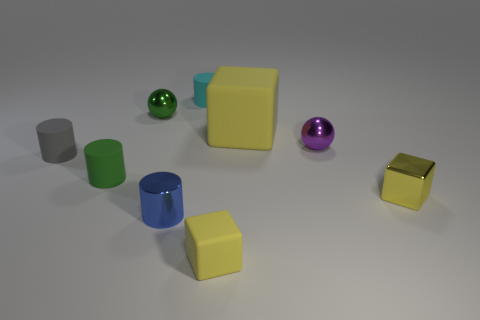What material is the green thing that is the same shape as the purple metal object?
Provide a succinct answer. Metal. Are there any other things that have the same material as the gray cylinder?
Your answer should be very brief. Yes. Are there any yellow things behind the blue thing?
Offer a terse response. Yes. What number of tiny things are there?
Offer a very short reply. 8. There is a tiny shiny ball behind the purple metal object; how many green things are to the left of it?
Offer a very short reply. 1. Is the color of the tiny metal cylinder the same as the object that is to the right of the purple metal thing?
Ensure brevity in your answer.  No. What number of yellow matte things are the same shape as the tiny yellow shiny thing?
Provide a succinct answer. 2. There is a small cylinder that is in front of the green matte thing; what is it made of?
Ensure brevity in your answer.  Metal. Does the small matte thing to the right of the tiny cyan cylinder have the same shape as the small gray rubber object?
Provide a succinct answer. No. Is there a brown matte object that has the same size as the yellow shiny block?
Offer a terse response. No. 